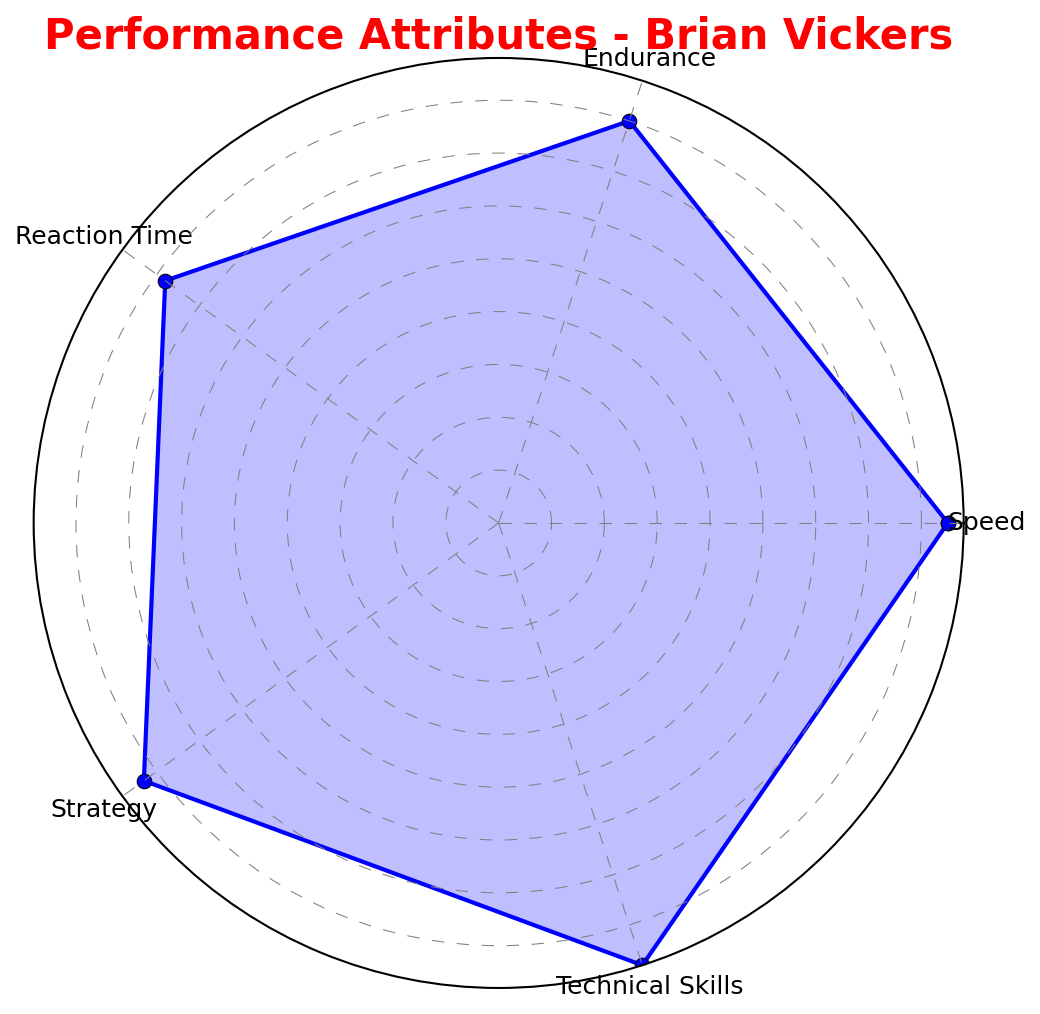What's the highest attribute value for Brian Vickers? The radar chart shows the performance attributes of Brian Vickers. To find the highest attribute, compare all the values (Speed: 85, Endurance: 80, Reaction Time: 78, Strategy: 83, Technical Skills: 88). The highest number is 88.
Answer: 88 Which attribute does Brian Vickers need the most improvement in? The radar chart allows us to compare all the attributes visually. The lowest value is the area where Brian Vickers needs the most improvement. The lowest value here is Reaction Time at 78.
Answer: Reaction Time How does the Technical Skills attribute of Brian Vickers compare to his Endurance? Compare the lengths of the lines representing Technical Skills and Endurance in the radar chart. Technical Skills is at 88, and Endurance is at 80, so Technical Skills is higher.
Answer: Technical Skills is higher What is the average value of Brian Vickers' attributes? To find the average, sum all attribute values (85 + 80 + 78 + 83 + 88 = 414) and divide by the number of attributes (5). The average is 414/5.
Answer: 82.8 If you were to sum the values of Speed and Strategy for Brian Vickers, what would it be? Sum the values of Speed (85) and Strategy (83). The sum is 85 + 83.
Answer: 168 Which attribute has a value closest to the average of all attributes for Brian Vickers? First, calculate the average of all attributes (82.8). Then, find which attribute value is closest to this. 
Values: Speed (85), Endurance (80), Reaction Time (78), Strategy (83), Technical Skills (88). 
Differences from average: Speed (85-82.8=2.2), Endurance (82.8-80=2.8), Reaction Time (82.8-78=4.8), Strategy (83-82.8=0.2), Technical Skills (88-82.8=5.2).
Strategy (83) is closest to 82.8.
Answer: Strategy How many attributes of Brian Vickers have a value above 80? Count the attributes with values greater than 80. Speed (85), Strategy (83), and Technical Skills (88). Three attributes are above 80.
Answer: 3 By how much does Brian Vickers' Speed exceed his Reaction Time? Subtract the value of Reaction Time (78) from Speed (85). The difference is 85 - 78.
Answer: 7 Which two attributes are the most closely matched in terms of their values for Brian Vickers? Compare the attribute values to find the smallest difference. The values are: Speed (85), Endurance (80), Reaction Time (78), Strategy (83), Technical Skills (88). 
The smallest difference is between Speed (85) and Technical Skills (88), with a difference of 3.
Answer: Speed and Technical Skills 